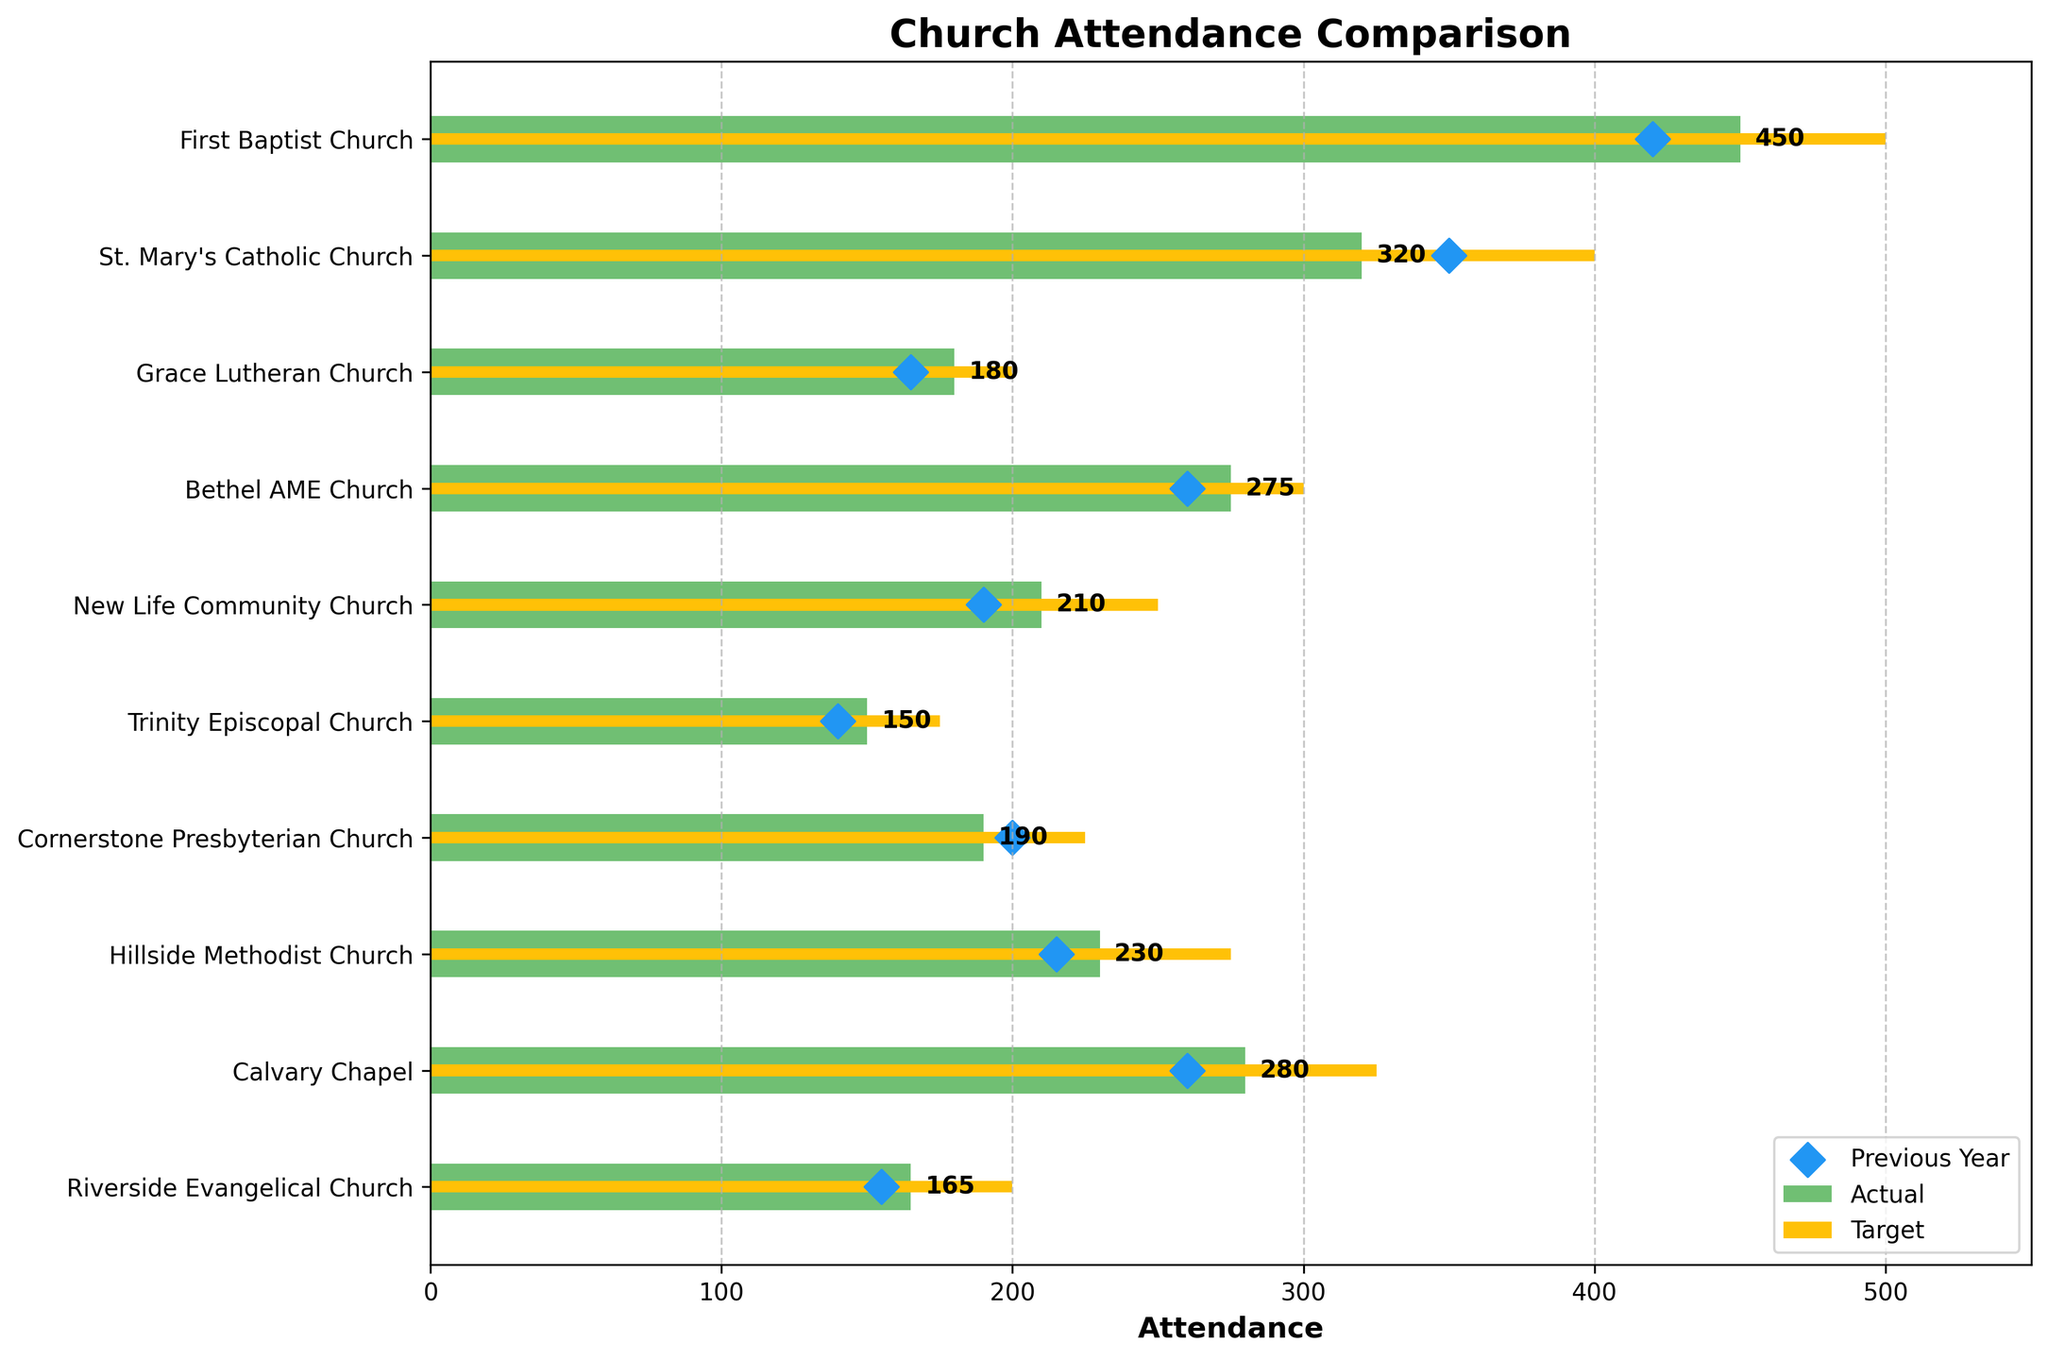What is the title of the chart? The title of the chart is located at the top and is typically a larger font size for easy visibility. It provides the overall context of the visualized data.
Answer: Church Attendance Comparison How many churches have their actual attendance below the target? To find this, compare the actual attendance bars to their corresponding target attendance bars for each church. Count the number of instances where the actual bar is shorter than the target bar.
Answer: 10 Which church has the highest actual attendance? Identify the longest green bar, as it represents the actual attendance. Look at the y-axis label of that bar for the church name.
Answer: First Baptist Church What is the difference in attendance between the previous year and the actual for Cornerstone Presbyterian Church? Locate Cornerstone Presbyterian Church on the y-axis, then identify the actual and previous year's attendance for this church. Subtract the previous year's attendance from the actual attendance.
Answer: -10 What is the mean actual attendance across all churches? Add up all the actual attendance values and then divide by the number of churches to get the mean. Calculation: (450 + 320 + 180 + 275 + 210 + 150 + 190 + 230 + 280 + 165) / 10 = 2450 / 10
Answer: 245 Which church saw the largest increase from the previous year to the actual attendance? For each church, subtract the previous year’s attendance from the actual attendance. Identify the church with the highest positive result. Calculation: First Baptist Church: 450 - 420 = 30, St. Mary's Catholic Church: 320 - 350 = -30, ...
Answer: First Baptist Church (30) How does Bethel AME Church's actual attendance compare to its target attendance? Examine the length of Bethel AME Church's actual attendance bar and compare it to the length of its target bar.
Answer: Below target What is the total target attendance for all churches combined? Add up all the target attendance values given for each church. Calculation: 500 + 400 + 200 + 300 + 250 + 175 + 225 + 275 + 325 + 200 = 2850
Answer: 2850 Which church exceeded its previous year's attendance by the highest percentage? For each church, calculate the percentage increase using the formula [(Actual - Previous Year)/Previous Year] * 100. Compare percentages to find the highest one. Calculation: [(450-420)/420]*100 = 7.14%, ...
Answer: First Baptist Church (7.14%) What is the range of actual attendance values? Identify the maximum and minimum actual attendance values from the bars. Subtract the minimum from the maximum to find the range. Range: 450 (max actual) - 150 (min actual) = 300
Answer: 300 